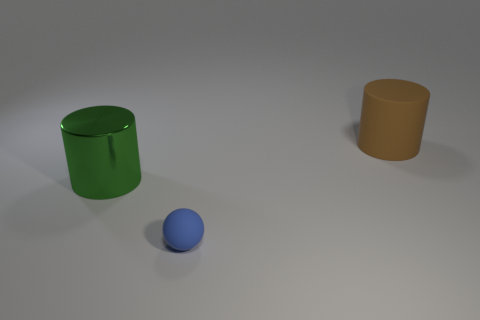Is there anything else that has the same material as the green object?
Your response must be concise. No. The object that is both behind the tiny matte ball and in front of the large brown rubber object is what color?
Provide a short and direct response. Green. How many cylinders are big brown rubber things or small blue matte things?
Keep it short and to the point. 1. Is the number of rubber things to the left of the large green metallic cylinder less than the number of big cyan metal objects?
Offer a very short reply. No. The large brown object that is made of the same material as the sphere is what shape?
Ensure brevity in your answer.  Cylinder. What number of objects are small blue rubber balls or shiny objects?
Your response must be concise. 2. What is the material of the big object in front of the cylinder that is to the right of the tiny blue object?
Keep it short and to the point. Metal. Is there a big blue block made of the same material as the brown cylinder?
Ensure brevity in your answer.  No. There is a large thing right of the matte thing that is in front of the big thing that is left of the tiny blue ball; what is its shape?
Give a very brief answer. Cylinder. What material is the brown cylinder?
Keep it short and to the point. Rubber. 